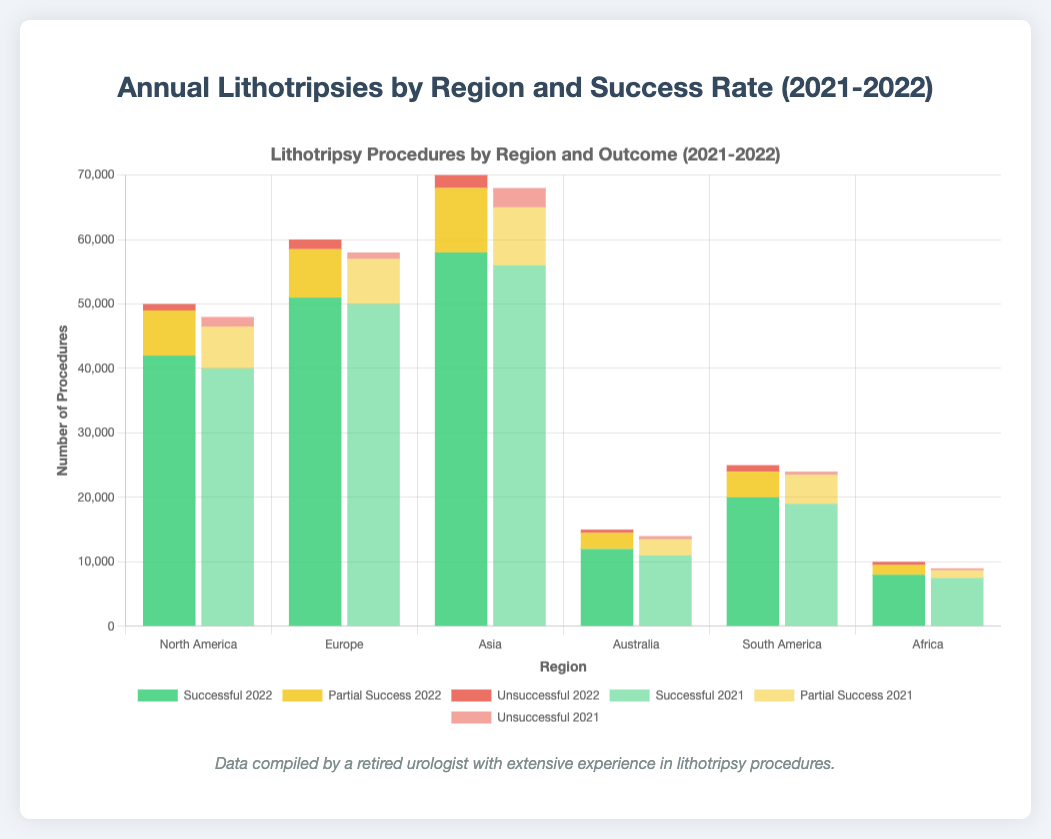Which region had the highest total number of lithotripsies performed in 2022? Look at the total number of lithotripsies per region in 2022. North America: 50,000, Europe: 60,000, Asia: 70,000, Australia: 15,000, South America: 25,000, Africa: 10,000. Asia has the highest total.
Answer: Asia What is the difference in the number of successful treatments between Asia in 2022 and Europe in 2021? Asia in 2022 had 58,000 successful treatments. Europe in 2021 had 50,000 successful treatments. The difference is 58,000 - 50,000.
Answer: 8,000 Compare the number of unsuccessful treatments in North America between 2021 and 2022. Which year had fewer unsuccessful treatments? In 2021, North America had 1,500 unsuccessful treatments. In 2022, it had 1,000 unsuccessful treatments. 2022 had fewer unsuccessful treatments.
Answer: 2022 By how much did the number of partially successful treatments in South America change from 2021 to 2022? South America had 4,500 partially successful treatments in 2021 and 4,000 in 2022. The change is 4,500 - 4,000.
Answer: 500 Which region had the smallest number of partially successful treatments in 2022? Compare the number of partially successful treatments in each region in 2022: North America: 7,000, Europe: 7,500, Asia: 10,000, Australia: 2,500, South America: 4,000, Africa: 1,500. Africa had the smallest number.
Answer: Africa How many more successful treatments were performed in Europe in 2022 compared to North America in 2021? Europe in 2022 had 51,000 successful treatments. North America in 2021 had 40,000 successful treatments. The difference is 51,000 - 40,000.
Answer: 11,000 What is the total number of lithotripsies performed in Australia over the two years? Sum the total lithotripsies performed in Australia in 2021 (14,000) and in 2022 (15,000): 14,000 + 15,000.
Answer: 29,000 Which visual attribute can be used to identify the partial success treatments for 2021? Partial success treatments for 2021 are represented by bars that are yellow and partially opaque.
Answer: Yellow, partially opaque By what percentage did the total number of lithotripsies increase in Africa from 2021 to 2022? Total in 2021: 9,000. Total in 2022: 10,000. Calculate the percentage increase: ((10,000 - 9,000) / 9,000) * 100.
Answer: 11.11% Which region had the highest number of unsuccessful treatments in 2022? Compare the number of unsuccessful treatments in each region in 2022: North America: 1,000, Europe: 1,500, Asia: 2,000, Australia: 500, South America: 1,000, Africa: 500. Asia had the highest number.
Answer: Asia 